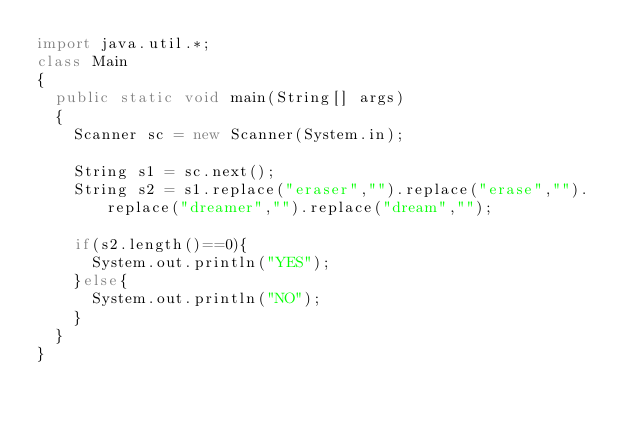Convert code to text. <code><loc_0><loc_0><loc_500><loc_500><_Java_>import java.util.*;
class Main
{
  public static void main(String[] args)
  {
    Scanner sc = new Scanner(System.in);
    
    String s1 = sc.next();
    String s2 = s1.replace("eraser","").replace("erase","").replace("dreamer","").replace("dream","");
    
    if(s2.length()==0){
      System.out.println("YES");
    }else{
      System.out.println("NO");
    }
  }
}</code> 